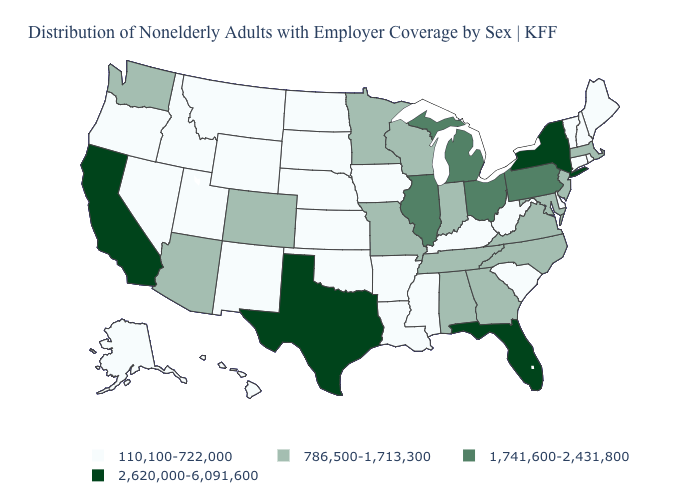Is the legend a continuous bar?
Answer briefly. No. Among the states that border South Carolina , which have the lowest value?
Give a very brief answer. Georgia, North Carolina. What is the value of Kansas?
Short answer required. 110,100-722,000. Which states have the highest value in the USA?
Concise answer only. California, Florida, New York, Texas. What is the lowest value in the USA?
Concise answer only. 110,100-722,000. What is the highest value in the USA?
Give a very brief answer. 2,620,000-6,091,600. What is the value of Virginia?
Write a very short answer. 786,500-1,713,300. How many symbols are there in the legend?
Answer briefly. 4. Does South Carolina have a lower value than Arizona?
Give a very brief answer. Yes. What is the value of Arkansas?
Short answer required. 110,100-722,000. Which states hav the highest value in the Northeast?
Write a very short answer. New York. Is the legend a continuous bar?
Write a very short answer. No. What is the lowest value in states that border Ohio?
Keep it brief. 110,100-722,000. 